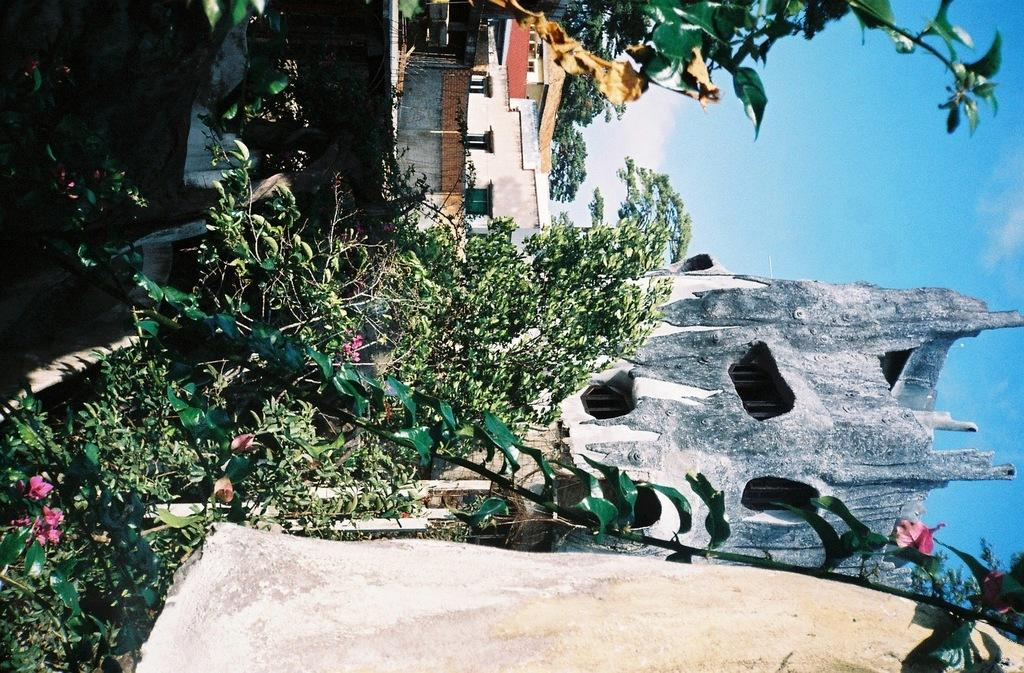What is located in the front of the image? There is a plant in the front of the image. What can be seen in the background of the image? There are houses and trees in the background of the image. What is the condition of the sky in the image? The sky is cloudy in the image. What type of lock is visible on the plant in the image? There is no lock present on the plant in the image. Can you tell me how many blades are attached to the plant in the image? There are no blades attached to the plant in the image. 